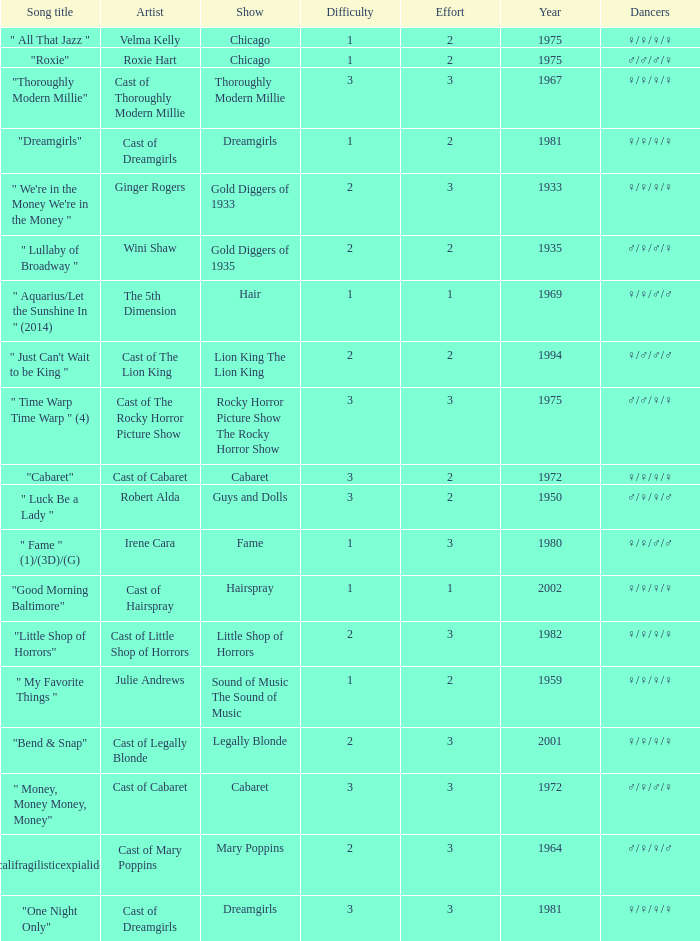What show featured the song "little shop of horrors"? Little Shop of Horrors. 